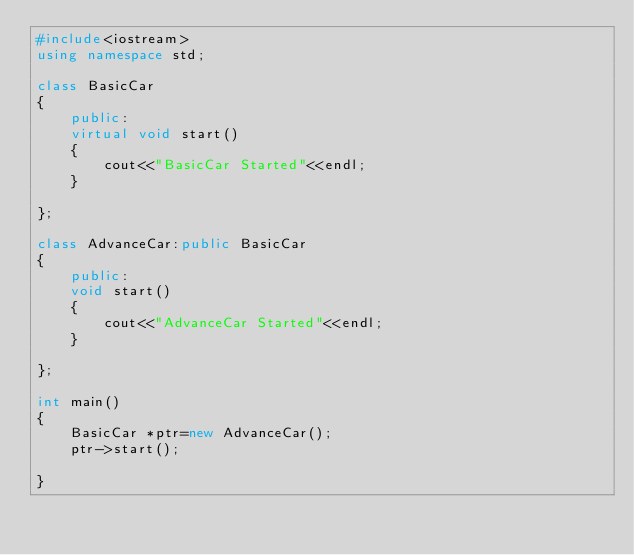<code> <loc_0><loc_0><loc_500><loc_500><_C++_>#include<iostream>
using namespace std;
    
class BasicCar
{
    public:
	virtual void start()
	{
		cout<<"BasicCar Started"<<endl;
	}
	
};
    
class AdvanceCar:public BasicCar
{
    public:
	void start()
	{
		cout<<"AdvanceCar Started"<<endl;
	}
	
};
    
int main()
{
	BasicCar *ptr=new AdvanceCar();
	ptr->start();
	    
}
    
</code> 